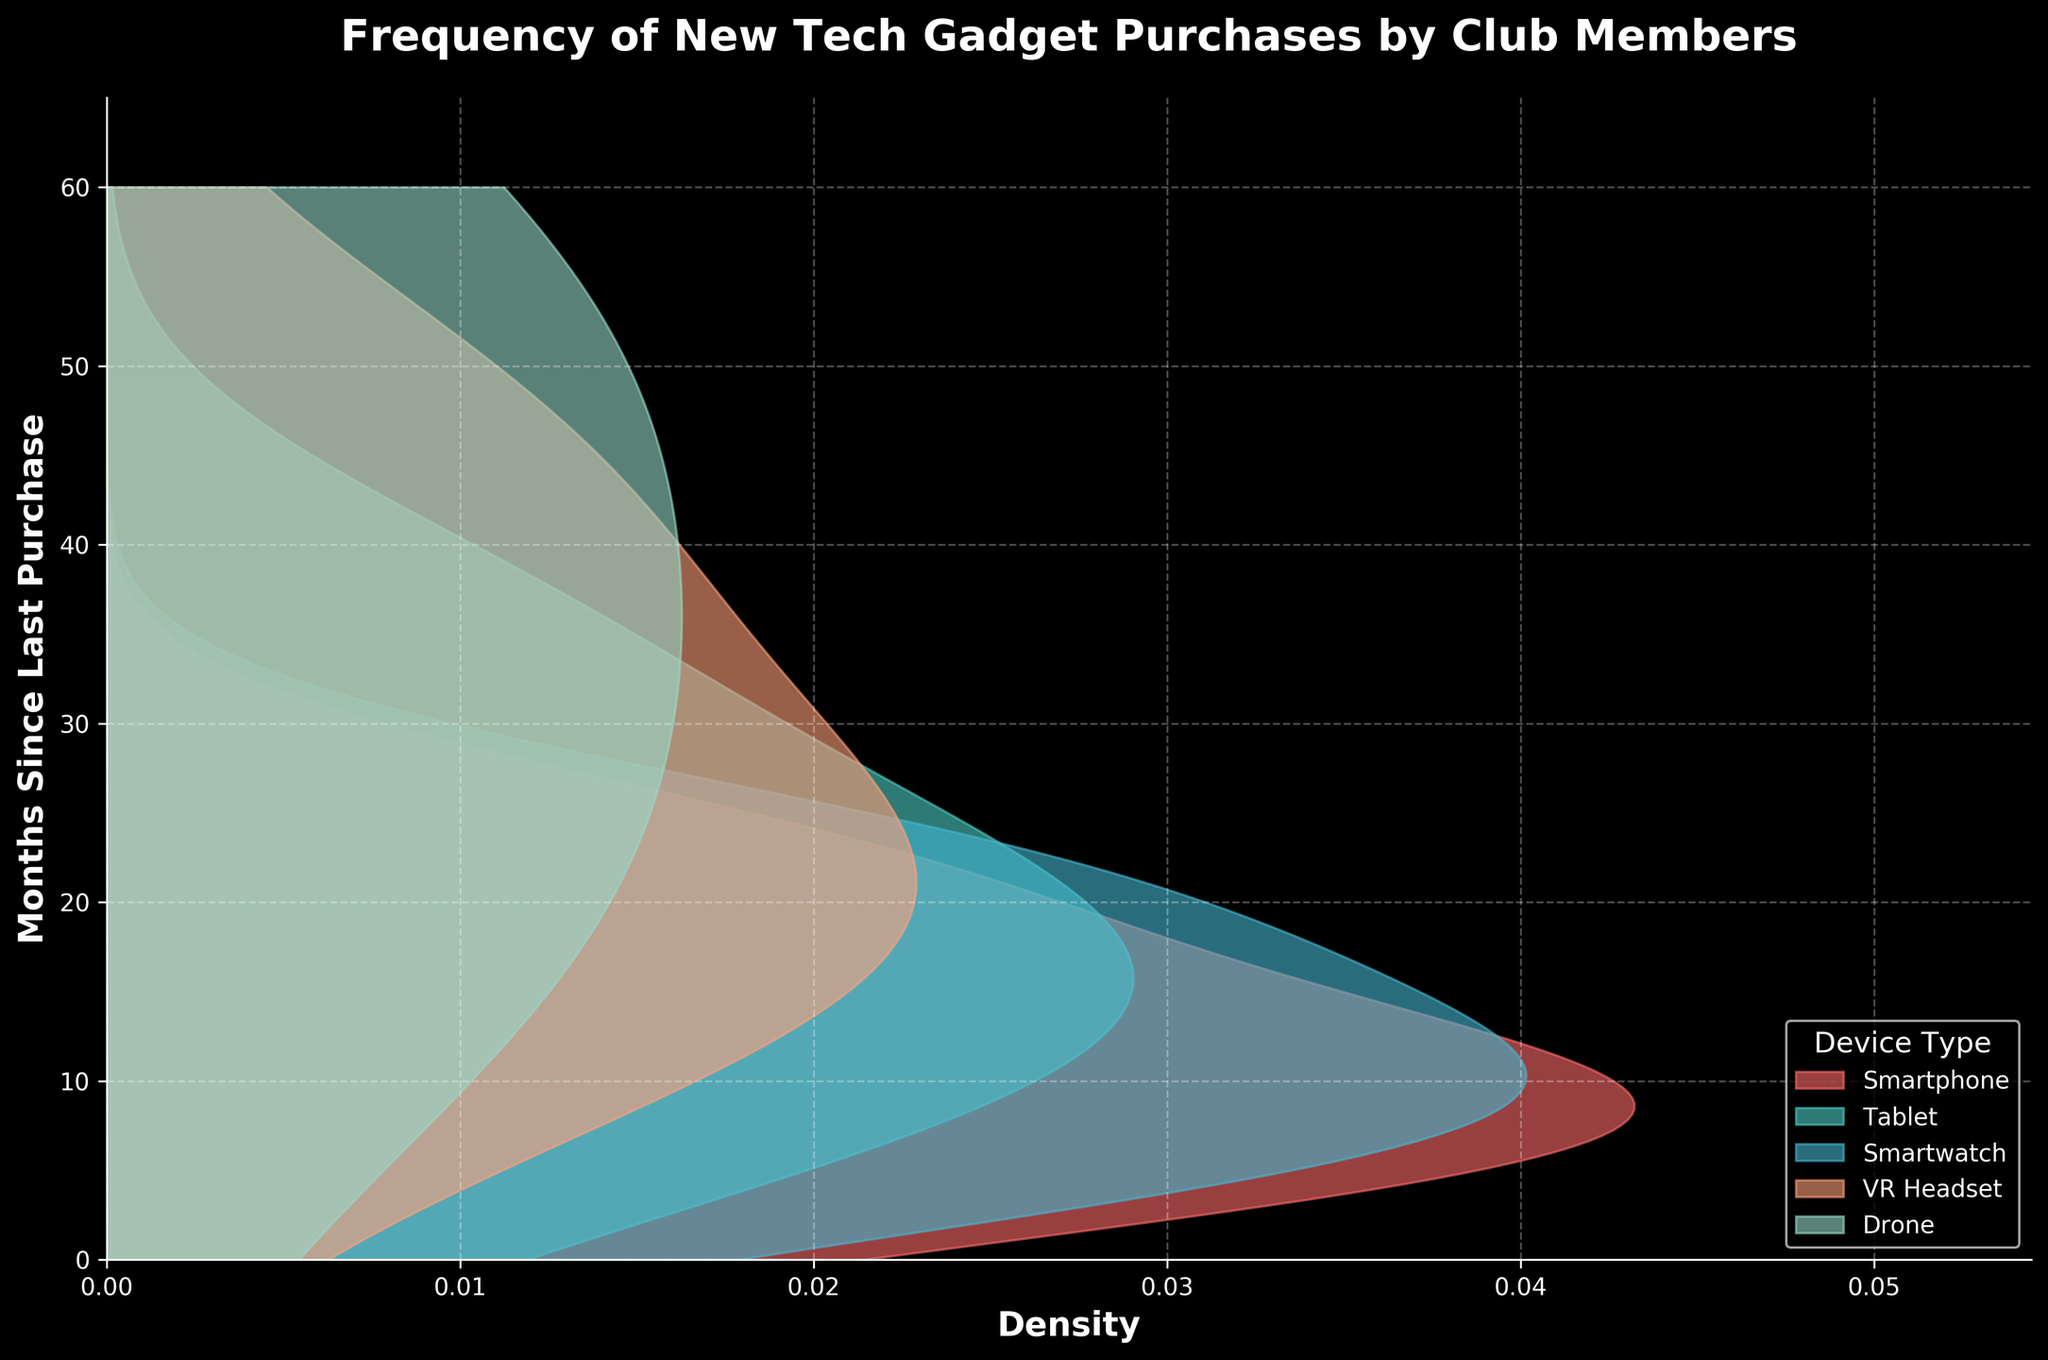What is the title of the plot? The title is displayed clearly at the top of the plot. It reads "Frequency of New Tech Gadget Purchases by Club Members".
Answer: Frequency of New Tech Gadget Purchases by Club Members What is the x-axis label? The x-axis label is displayed horizontally and it reads "Density".
Answer: Density What is the y-axis label? The y-axis label is displayed vertically on the left side and it reads "Months Since Last Purchase".
Answer: Months Since Last Purchase How many device types are represented in the plot? The legend lists all the device types represented in the plot. There are 5 device types: Smartphone, Tablet, Smartwatch, VR Headset, and Drone.
Answer: 5 Which device type shows the highest density? The height of the peak in each curve represents the density. Smartphone's curve has the highest peak.
Answer: Smartphone How do the density distributions of VR Headset and Drone purchases compare? The curves for VR Headset and Drone are used to compare their peaks and spread. VR Headset purchases have a peak around 24 months, showing a higher density than Drone which has a more spread-out distribution with less density at any given point.
Answer: VR Headset has higher density at its peak compared to Drone What is the approximate range of months since the last purchase for Tablets? The distribution for Tablets spans from the lowest to the highest months value on the x-axis, indicating purchases range from 6 to 36 months.
Answer: 6 to 36 months Which device type shows purchases with the least frequent initial purchase period? By examining the distributions, Drone has the least frequent initial purchase period, starting at the 12-month mark, while others show higher density at shorter times.
Answer: Drone Is there any device with multiple peaks in their density distribution? The density curves are observed to identify any additional peaks. Both VR Headset and Drone show multiple peaks, indicating varied purchase frequencies.
Answer: VR Headset, Drone Are there any device types with no purchases before 12 months? The curves from the beginning (0 months) up to 12 months are checked. Drone and Tablet show no density before 12 months.
Answer: Drone, Tablet 